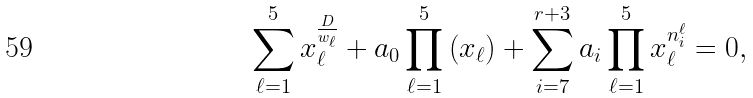<formula> <loc_0><loc_0><loc_500><loc_500>\sum _ { \ell = 1 } ^ { 5 } x _ { \ell } ^ { \frac { D } { w _ { \ell } } } + a _ { 0 } \prod _ { \ell = 1 } ^ { 5 } \left ( x _ { \ell } \right ) + \sum _ { i = 7 } ^ { r + 3 } a _ { i } \prod _ { \ell = 1 } ^ { 5 } x _ { \ell } ^ { n ^ { \ell } _ { i } } = 0 ,</formula> 